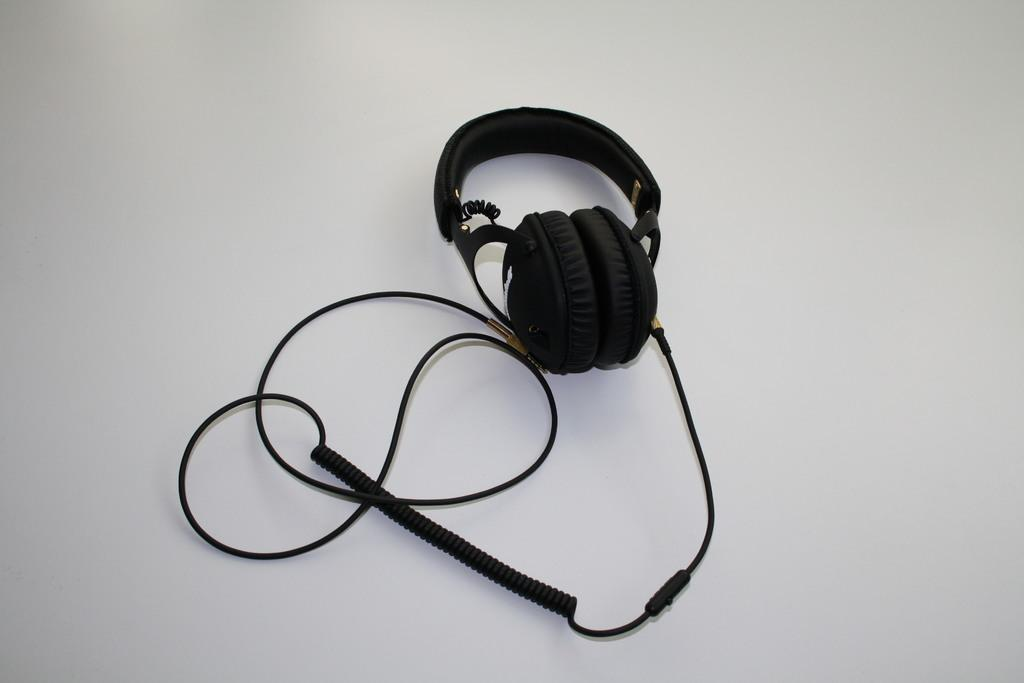What type of device is visible in the image? There is a black color headset in the image. What is the color of the surface on which the headset is placed? The headset is placed on a white surface. What language is spoken by the pin in the image? There is no pin present in the image, and therefore no language can be attributed to it. 